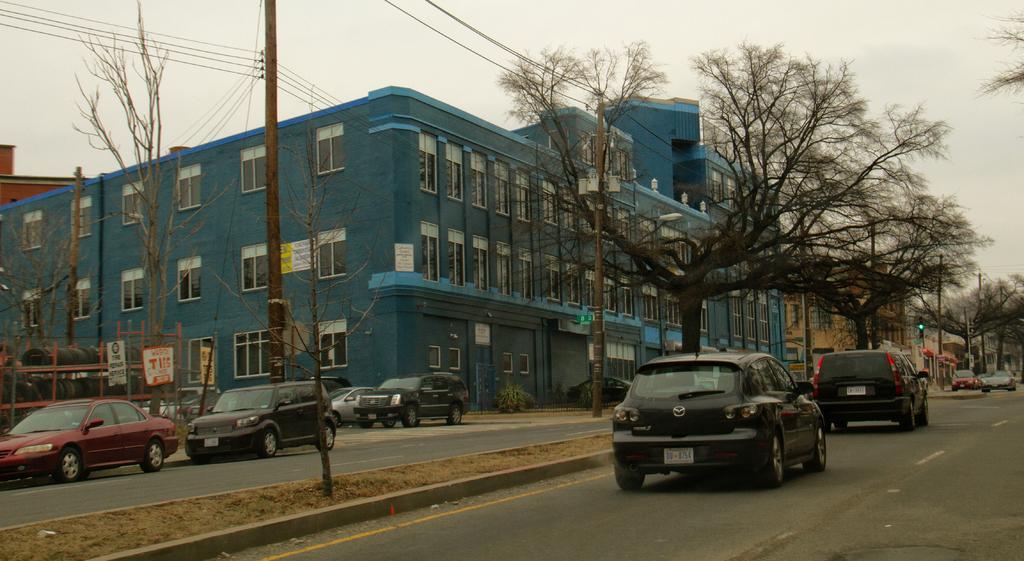Please provide a concise description of this image. This is an outside view. At the bottom of the image I can see few cars on the road. In the background there are some buildings and trees. Beside the road I can see a pole along with the wires. At the top I can see the sky. 